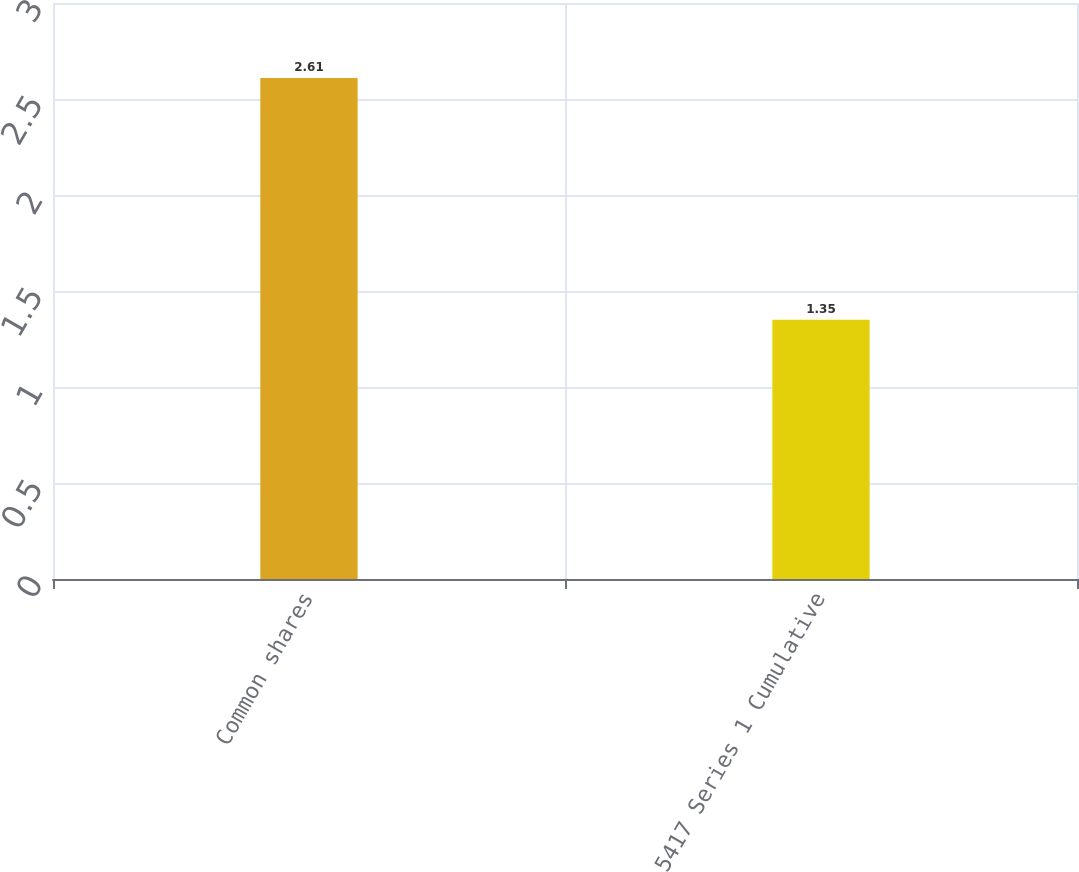<chart> <loc_0><loc_0><loc_500><loc_500><bar_chart><fcel>Common shares<fcel>5417 Series 1 Cumulative<nl><fcel>2.61<fcel>1.35<nl></chart> 